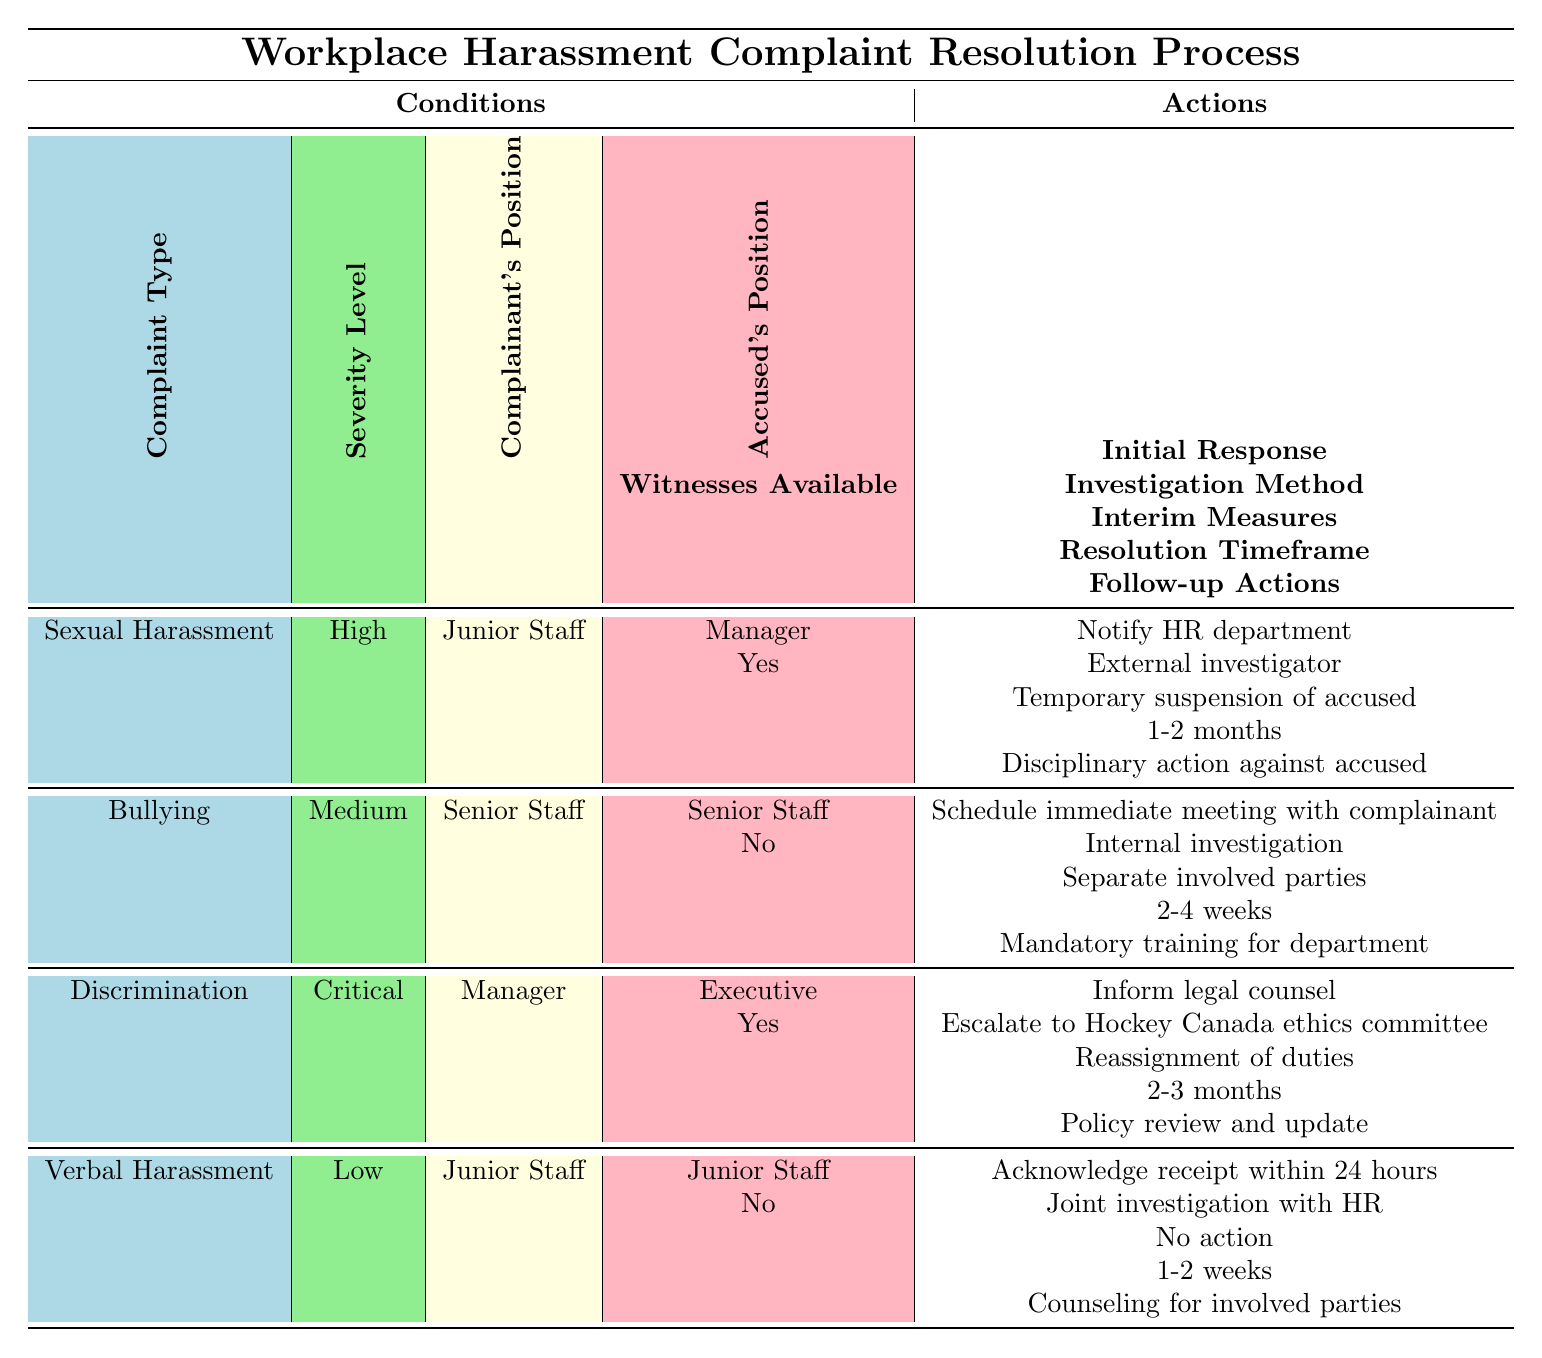What action is taken when the complaint is about Sexual Harassment and is reported by Junior Staff? For complaints about Sexual Harassment reported by Junior Staff, the action taken is to notify the HR department. This is directly indicated in the table corresponding to the conditions of Sexual Harassment, High severity, with the complainant as Junior Staff and the accused as Manager.
Answer: Notify HR department What is the investigation method used for a Bullying complaint with Medium severity? In cases of Bullying complaints that are assessed as Medium severity, the investigation method is an Internal investigation as shown in the row corresponding to Bullying, Medium severity, with Senior Staff as both the complainant and accused, and no witnesses available.
Answer: Internal investigation How long is the resolution timeframe for a Discrimination complaint with a Critical level of severity when witnesses are available? The resolution timeframe for a Discrimination complaint classified as Critical severity with witnesses available is 2-3 months. This is clearly stated in the conditions that match the criteria in the relevant row of the table.
Answer: 2-3 months Is there a need for follow-up actions in cases where there is no availability of witnesses for Verbal Harassment? Yes, even if there are no witnesses available, follow-up actions such as Counseling for involved parties are still required in cases of Verbal Harassment as indicated in the corresponding row of the table.
Answer: Yes What is the difference in resolution timeframes between Sexual Harassment (High severity) and Bullying (Medium severity)? The resolution timeframe for Sexual Harassment (High severity) is 1-2 months, while for Bullying (Medium severity) it is 2-4 weeks. To find the difference, convert both timeframes to weeks: 1-2 months is approximately 4-8 weeks. The difference between 8 weeks (max of Sexual Harassment) and 2 weeks (min of Bullying) is 6 weeks. So, the resolution timeframe for Sexual Harassment is longer by 6 weeks at maximum.
Answer: 6 weeks What immediate action is taken if the complaint is Verbal Harassment and the severity is Low? The immediate action for a complaint categorized as Verbal Harassment with a Low severity level is to acknowledge receipt within 24 hours. This information is found in the row that aligns with the specific conditions of the complaint type and severity level.
Answer: Acknowledge receipt within 24 hours 